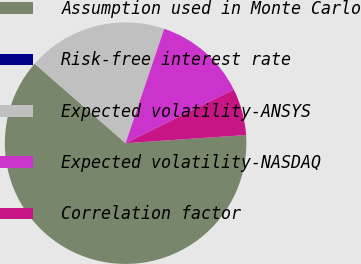Convert chart. <chart><loc_0><loc_0><loc_500><loc_500><pie_chart><fcel>Assumption used in Monte Carlo<fcel>Risk-free interest rate<fcel>Expected volatility-ANSYS<fcel>Expected volatility-NASDAQ<fcel>Correlation factor<nl><fcel>62.49%<fcel>0.0%<fcel>18.75%<fcel>12.5%<fcel>6.25%<nl></chart> 